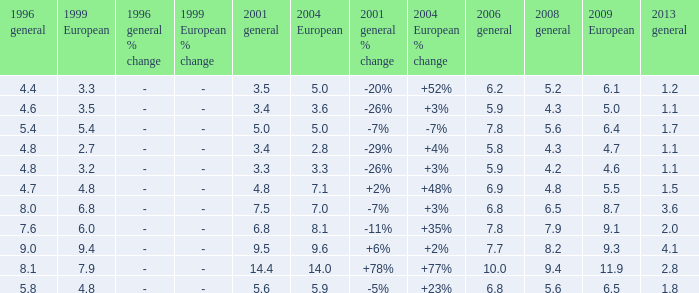What is the highest value for general 2008 when there is less than 5.5 in European 2009, more than 5.8 in general 2006, more than 3.3 in general 2001, and less than 3.6 for 2004 European? None. 